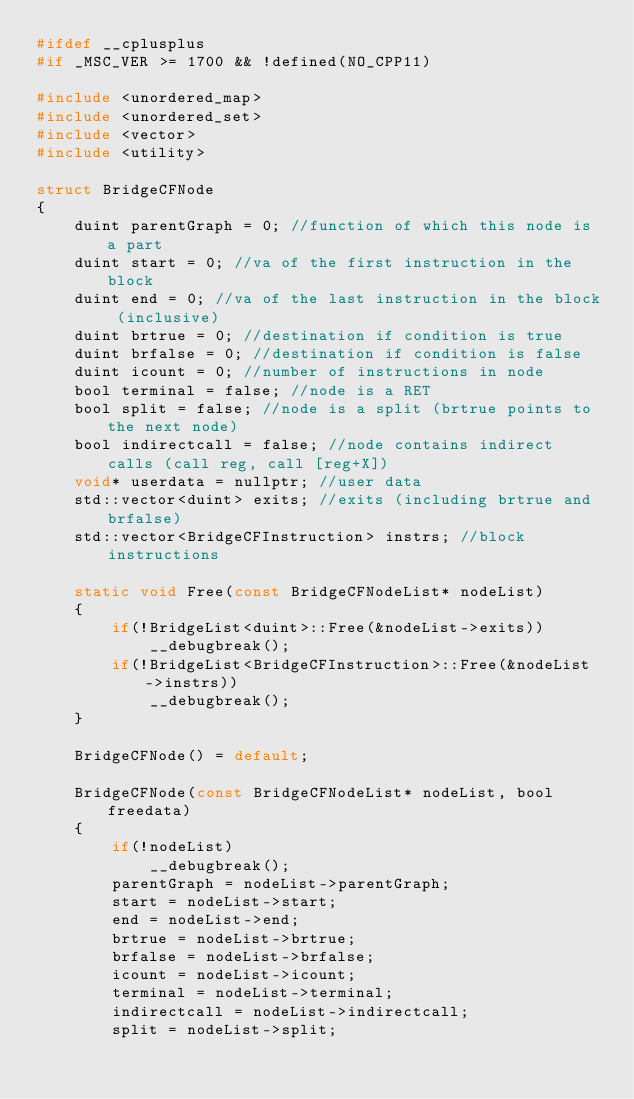<code> <loc_0><loc_0><loc_500><loc_500><_C_>#ifdef __cplusplus
#if _MSC_VER >= 1700 && !defined(NO_CPP11)

#include <unordered_map>
#include <unordered_set>
#include <vector>
#include <utility>

struct BridgeCFNode
{
    duint parentGraph = 0; //function of which this node is a part
    duint start = 0; //va of the first instruction in the block
    duint end = 0; //va of the last instruction in the block (inclusive)
    duint brtrue = 0; //destination if condition is true
    duint brfalse = 0; //destination if condition is false
    duint icount = 0; //number of instructions in node
    bool terminal = false; //node is a RET
    bool split = false; //node is a split (brtrue points to the next node)
    bool indirectcall = false; //node contains indirect calls (call reg, call [reg+X])
    void* userdata = nullptr; //user data
    std::vector<duint> exits; //exits (including brtrue and brfalse)
    std::vector<BridgeCFInstruction> instrs; //block instructions

    static void Free(const BridgeCFNodeList* nodeList)
    {
        if(!BridgeList<duint>::Free(&nodeList->exits))
            __debugbreak();
        if(!BridgeList<BridgeCFInstruction>::Free(&nodeList->instrs))
            __debugbreak();
    }

    BridgeCFNode() = default;

    BridgeCFNode(const BridgeCFNodeList* nodeList, bool freedata)
    {
        if(!nodeList)
            __debugbreak();
        parentGraph = nodeList->parentGraph;
        start = nodeList->start;
        end = nodeList->end;
        brtrue = nodeList->brtrue;
        brfalse = nodeList->brfalse;
        icount = nodeList->icount;
        terminal = nodeList->terminal;
        indirectcall = nodeList->indirectcall;
        split = nodeList->split;</code> 